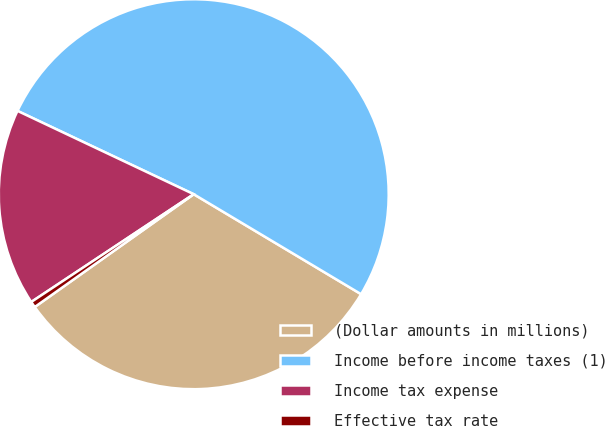Convert chart to OTSL. <chart><loc_0><loc_0><loc_500><loc_500><pie_chart><fcel>(Dollar amounts in millions)<fcel>Income before income taxes (1)<fcel>Income tax expense<fcel>Effective tax rate<nl><fcel>31.61%<fcel>51.54%<fcel>16.35%<fcel>0.5%<nl></chart> 